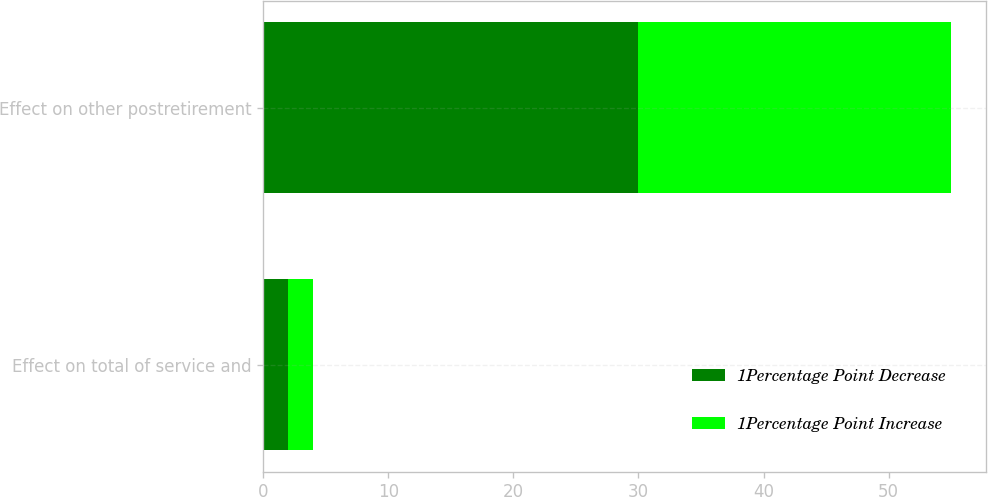Convert chart to OTSL. <chart><loc_0><loc_0><loc_500><loc_500><stacked_bar_chart><ecel><fcel>Effect on total of service and<fcel>Effect on other postretirement<nl><fcel>1Percentage Point Decrease<fcel>2<fcel>30<nl><fcel>1Percentage Point Increase<fcel>2<fcel>25<nl></chart> 